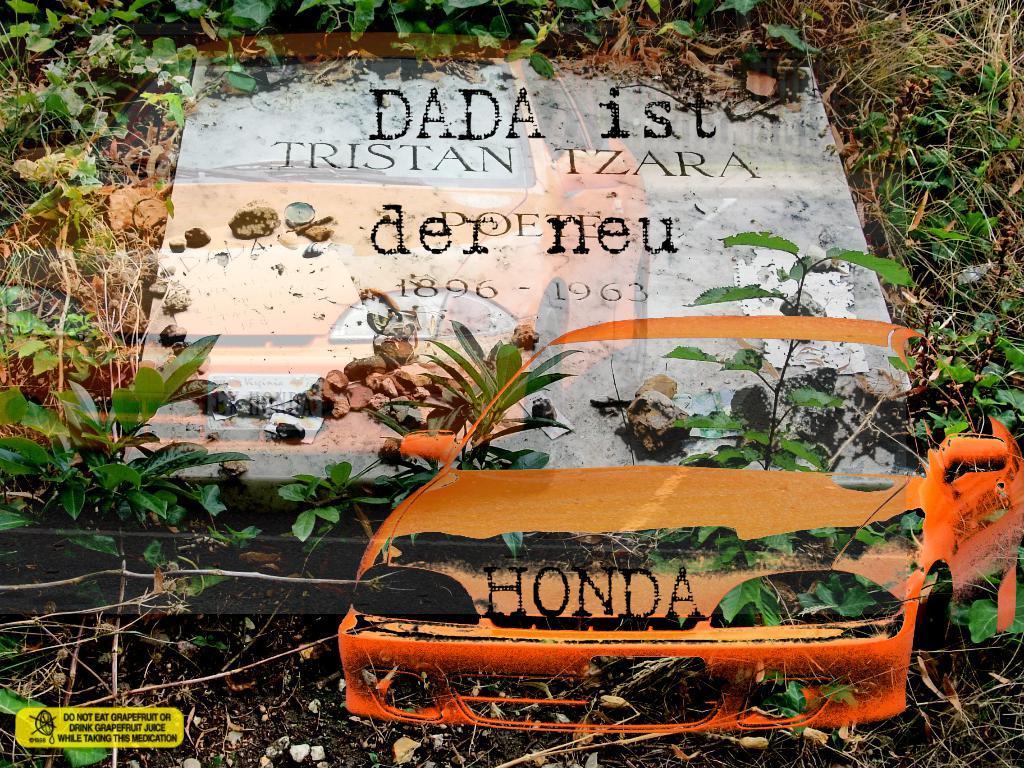Please provide a concise description of this image. In this picture there is a gravestone, around the gravestone there are plants, soil and grass. The picture has a car watermark. 